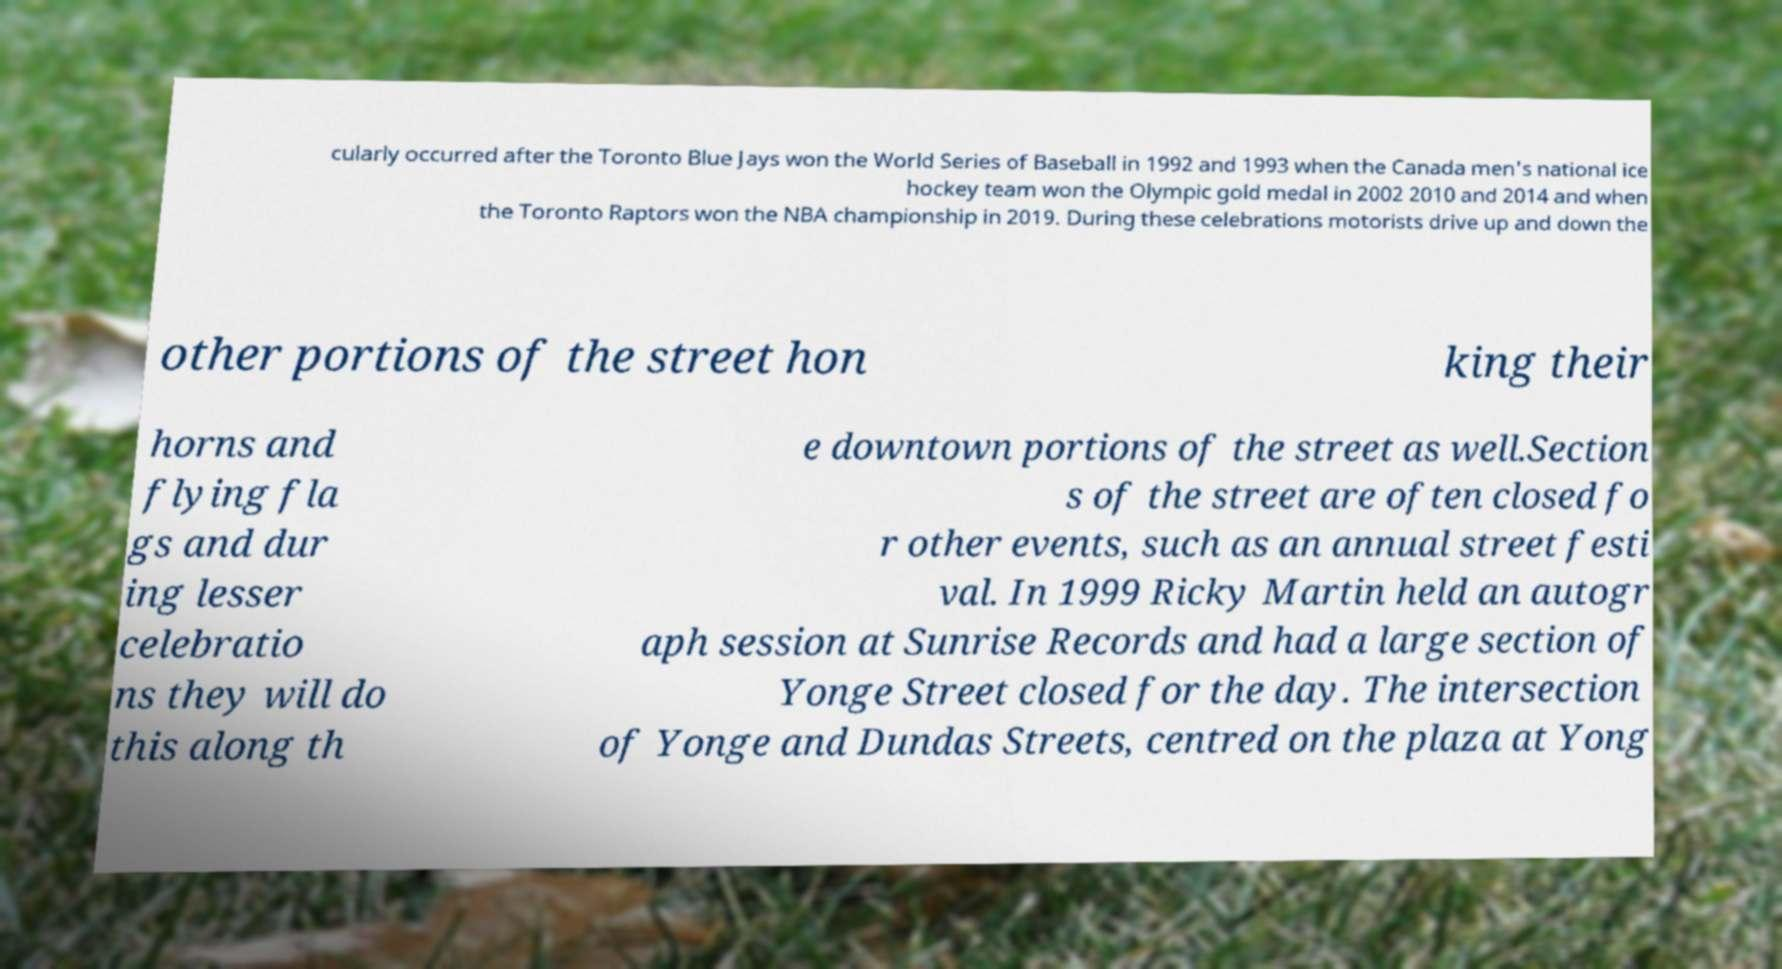For documentation purposes, I need the text within this image transcribed. Could you provide that? cularly occurred after the Toronto Blue Jays won the World Series of Baseball in 1992 and 1993 when the Canada men's national ice hockey team won the Olympic gold medal in 2002 2010 and 2014 and when the Toronto Raptors won the NBA championship in 2019. During these celebrations motorists drive up and down the other portions of the street hon king their horns and flying fla gs and dur ing lesser celebratio ns they will do this along th e downtown portions of the street as well.Section s of the street are often closed fo r other events, such as an annual street festi val. In 1999 Ricky Martin held an autogr aph session at Sunrise Records and had a large section of Yonge Street closed for the day. The intersection of Yonge and Dundas Streets, centred on the plaza at Yong 